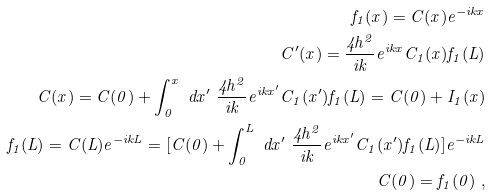<formula> <loc_0><loc_0><loc_500><loc_500>f _ { 1 } ( x ) = C ( x ) e ^ { - i k x } \\ C ^ { \prime } ( x ) = \frac { 4 h ^ { 2 } } { i k } e ^ { i k x } C _ { 1 } ( x ) f _ { 1 } ( L ) \\ C ( x ) = C ( 0 ) + \int _ { 0 } ^ { x } \ d x ^ { \prime } \ \frac { 4 h ^ { 2 } } { i k } e ^ { i k x ^ { \prime } } C _ { 1 } ( x ^ { \prime } ) f _ { 1 } ( L ) = C ( 0 ) + I _ { 1 } ( x ) \\ f _ { 1 } ( L ) = C ( L ) e ^ { - i k L } = [ C ( 0 ) + \int _ { 0 } ^ { L } \ d x ^ { \prime } \ \frac { 4 h ^ { 2 } } { i k } e ^ { i k x ^ { \prime } } C _ { 1 } ( x ^ { \prime } ) f _ { 1 } ( L ) ] e ^ { - i k L } \\ C ( 0 ) = f _ { 1 } ( 0 ) \ ,</formula> 